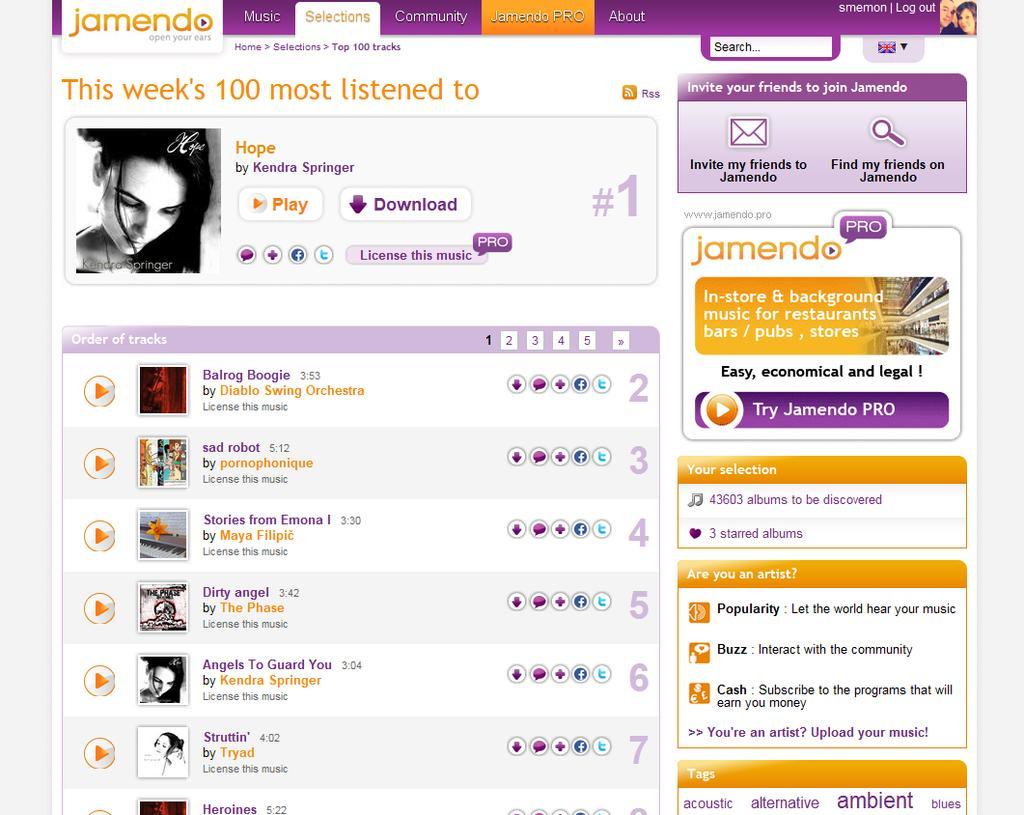Describe this image in one or two sentences. In this image I see a site on which there are pictures and I see many words and numbers written and I see the flag over here. 